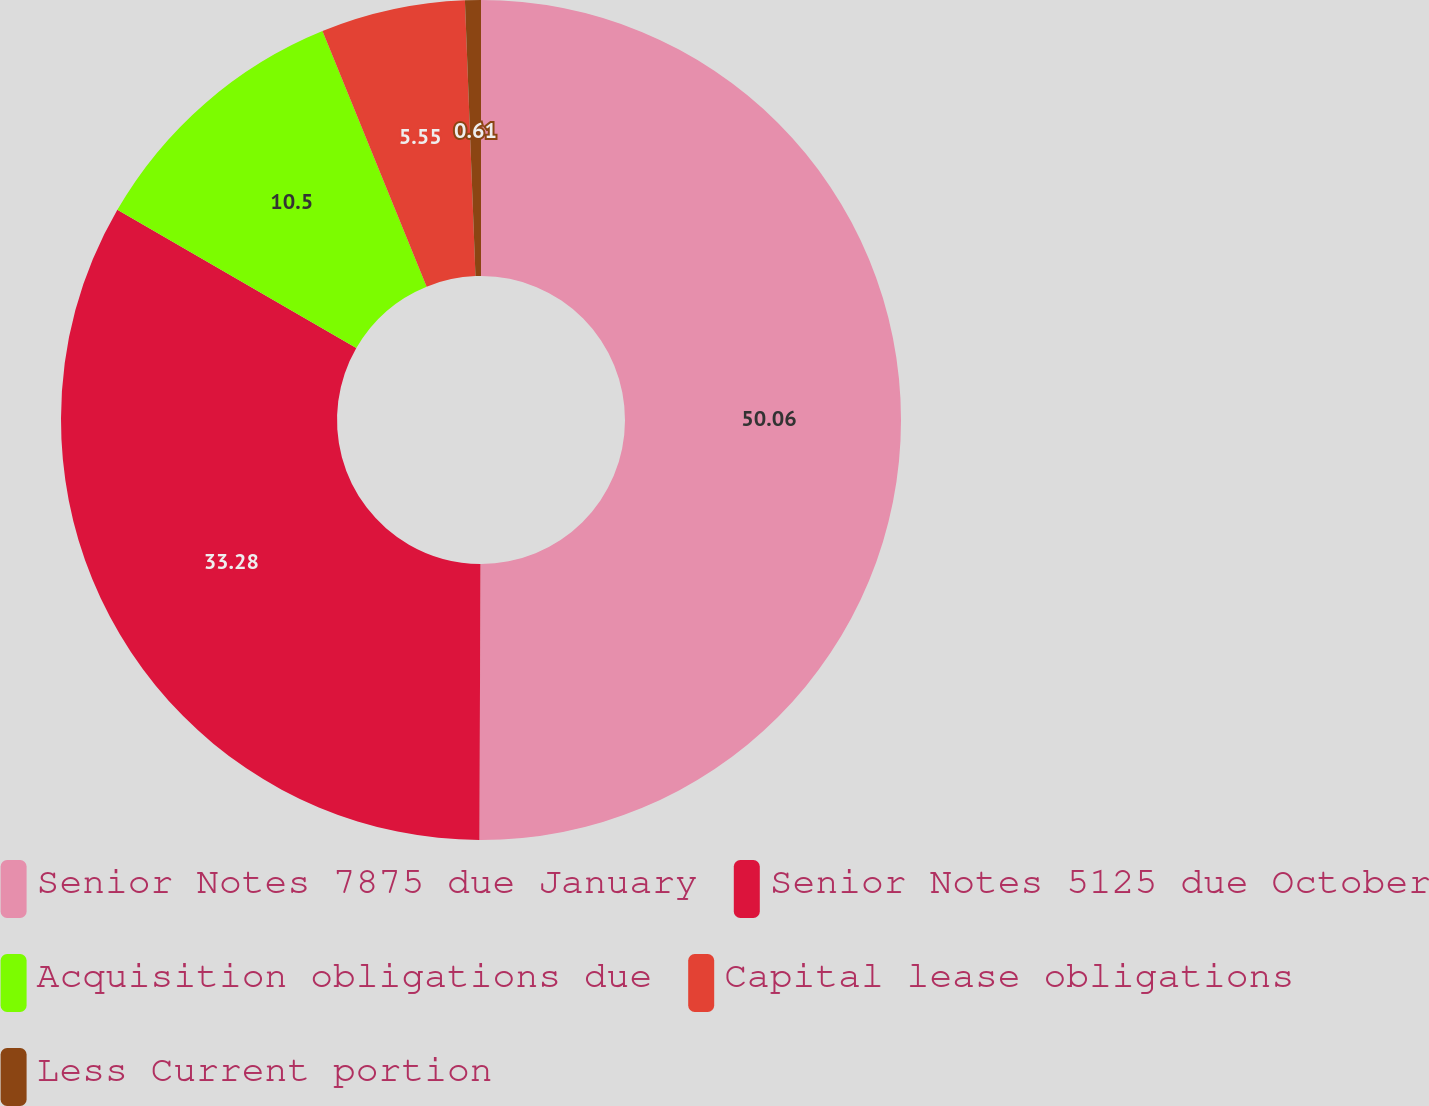Convert chart to OTSL. <chart><loc_0><loc_0><loc_500><loc_500><pie_chart><fcel>Senior Notes 7875 due January<fcel>Senior Notes 5125 due October<fcel>Acquisition obligations due<fcel>Capital lease obligations<fcel>Less Current portion<nl><fcel>50.06%<fcel>33.28%<fcel>10.5%<fcel>5.55%<fcel>0.61%<nl></chart> 